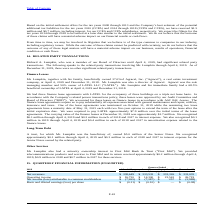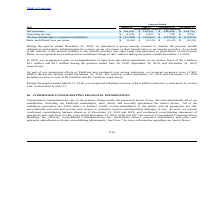According to Consolidated Communications Holdings's financial document, What was the non-cash pension settlement charge recognized in the quarter ended 31 December 2019? According to the financial document, $6.7 million. The relevant text states: "recognized a non-cash pension settlement charge of $6.7 million during the quarter ended December 31, 2019...." Also, What was the gain on extinguishment of debt recognized in June 2019? According to the financial document, $0.3 million. The relevant text states: "recognized $0.1 million through April 4, 2019 and $0.3 million in each of 2018 and 2017 in interest expense. We also recognized $0.1 million in 2019 through April..." Also, What was the gain on extinguishment of debt recognized in December 2019? According to the financial document, $3.1 million. The relevant text states: "our Senior Notes of $0.3 million, $1.1 million and $3.1 million during the quarters ended June 30, 2019, September 30, 2019, and December 31, 2019, respectively...." Also, can you calculate: What was the increase / (decrease) in the net revenues from March 31, 2019 to December 31 2019? Based on the calculation: 331,035 - 338,649, the result is -7614 (in thousands). This is based on the information: "Net revenues $ 338,649 $ 333,532 $ 333,326 $ 331,035 Net revenues $ 338,649 $ 333,532 $ 333,326 $ 331,035..." The key data points involved are: 331,035, 338,649. Also, can you calculate: What is the average Operating income for each quarter in 2019? To answer this question, I need to perform calculations using the financial data. The calculation is: (16,720 + 14,300 + 23,542 + 26,719) / 4, which equals 20320.25 (in thousands). This is based on the information: "Operating income $ 16,720 $ 14,300 $ 23,542 $ 26,719 Operating income $ 16,720 $ 14,300 $ 23,542 $ 26,719 Operating income $ 16,720 $ 14,300 $ 23,542 $ 26,719 Operating income $ 16,720 $ 14,300 $ 23,5..." The key data points involved are: 14,300, 16,720, 23,542. Also, can you calculate: What was the total percentage increase / (decrease) in the Net income (loss) attributable to common stockholders from March 2019 to December 2019? To answer this question, I need to perform calculations using the financial data. The calculation is: -5,988 / -7,265 - 1, which equals -17.58 (percentage). This is based on the information: "common stockholders $ (7,265) $ (7,387) $ 257 $ (5,988) ome (loss) attributable to common stockholders $ (7,265) $ (7,387) $ 257 $ (5,988)..." The key data points involved are: 5,988, 7,265. 